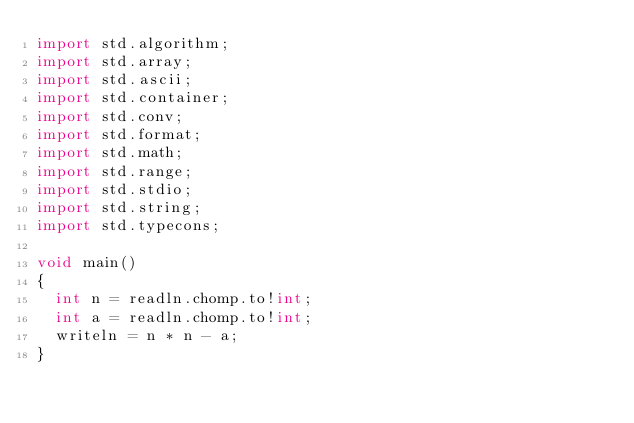<code> <loc_0><loc_0><loc_500><loc_500><_D_>import std.algorithm;
import std.array;
import std.ascii;
import std.container;
import std.conv;
import std.format;
import std.math;
import std.range;
import std.stdio;
import std.string;
import std.typecons;

void main()
{
  int n = readln.chomp.to!int;
  int a = readln.chomp.to!int;
  writeln = n * n - a;
}
</code> 